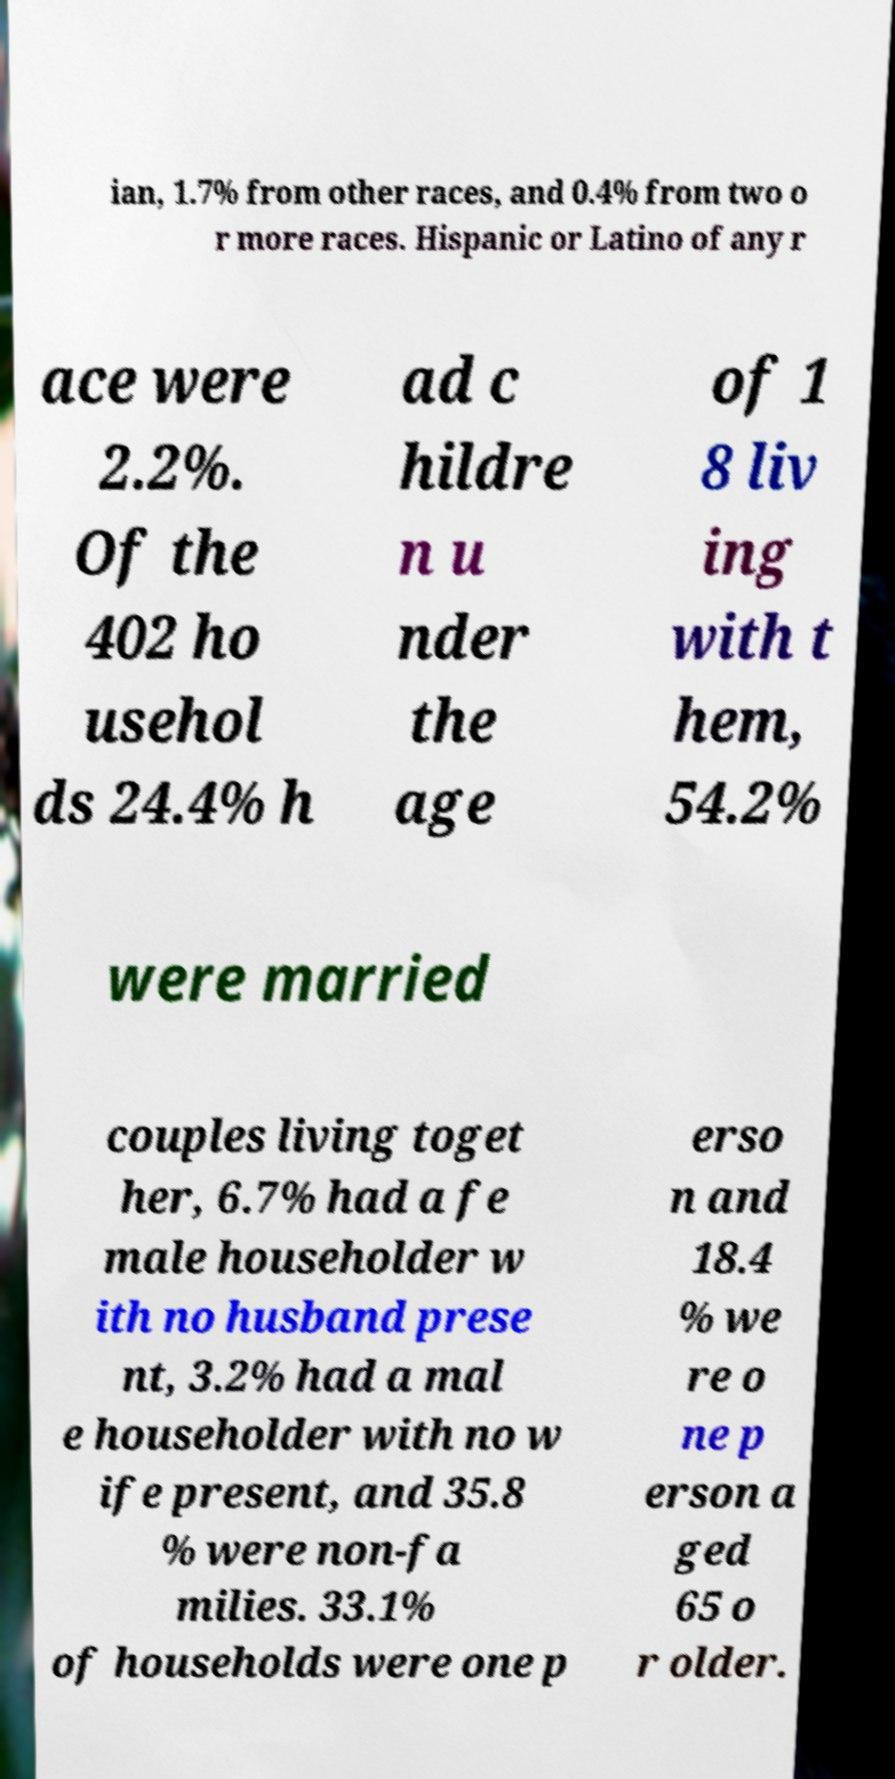For documentation purposes, I need the text within this image transcribed. Could you provide that? ian, 1.7% from other races, and 0.4% from two o r more races. Hispanic or Latino of any r ace were 2.2%. Of the 402 ho usehol ds 24.4% h ad c hildre n u nder the age of 1 8 liv ing with t hem, 54.2% were married couples living toget her, 6.7% had a fe male householder w ith no husband prese nt, 3.2% had a mal e householder with no w ife present, and 35.8 % were non-fa milies. 33.1% of households were one p erso n and 18.4 % we re o ne p erson a ged 65 o r older. 